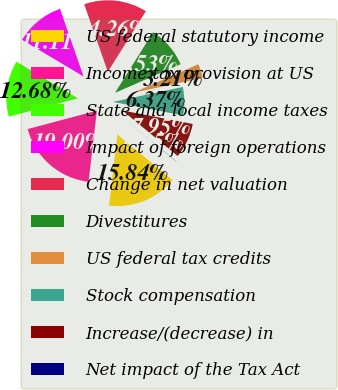Convert chart. <chart><loc_0><loc_0><loc_500><loc_500><pie_chart><fcel>US federal statutory income<fcel>Income tax provision at US<fcel>State and local income taxes<fcel>Impact of foreign operations<fcel>Change in net valuation<fcel>Divestitures<fcel>US federal tax credits<fcel>Stock compensation<fcel>Increase/(decrease) in<fcel>Net impact of the Tax Act<nl><fcel>15.84%<fcel>19.0%<fcel>12.68%<fcel>11.11%<fcel>14.26%<fcel>9.53%<fcel>3.21%<fcel>6.37%<fcel>7.95%<fcel>0.05%<nl></chart> 